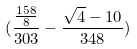<formula> <loc_0><loc_0><loc_500><loc_500>( \frac { \frac { 1 5 8 } { 8 } } { 3 0 3 } - \frac { \sqrt { 4 } - 1 0 } { 3 4 8 } )</formula> 